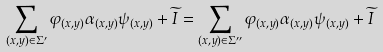Convert formula to latex. <formula><loc_0><loc_0><loc_500><loc_500>\sum _ { ( x , y ) \in \Sigma ^ { \prime } } \varphi _ { ( x , y ) } \alpha _ { ( x , y ) } \psi _ { ( x , y ) } + \widetilde { I } = \sum _ { ( x , y ) \in \Sigma ^ { \prime \prime } } \varphi _ { ( x , y ) } \alpha _ { ( x , y ) } \psi _ { ( x , y ) } + \widetilde { I } \</formula> 